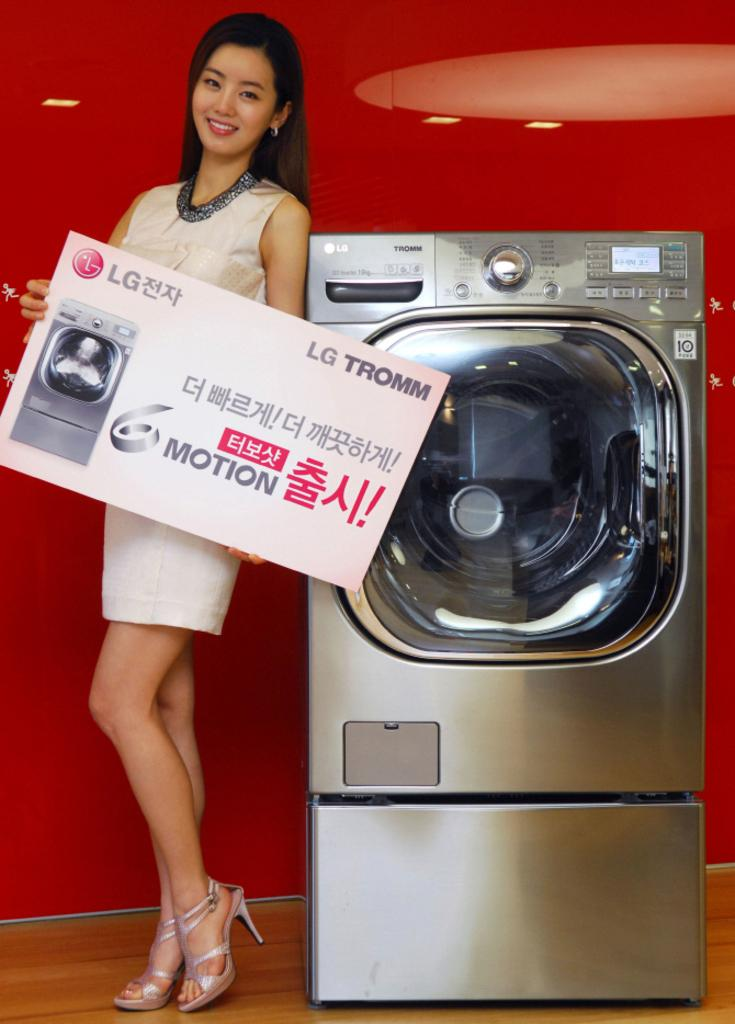<image>
Relay a brief, clear account of the picture shown. A woman holding an advert for an LG washing machine poses next to the washing machine. 